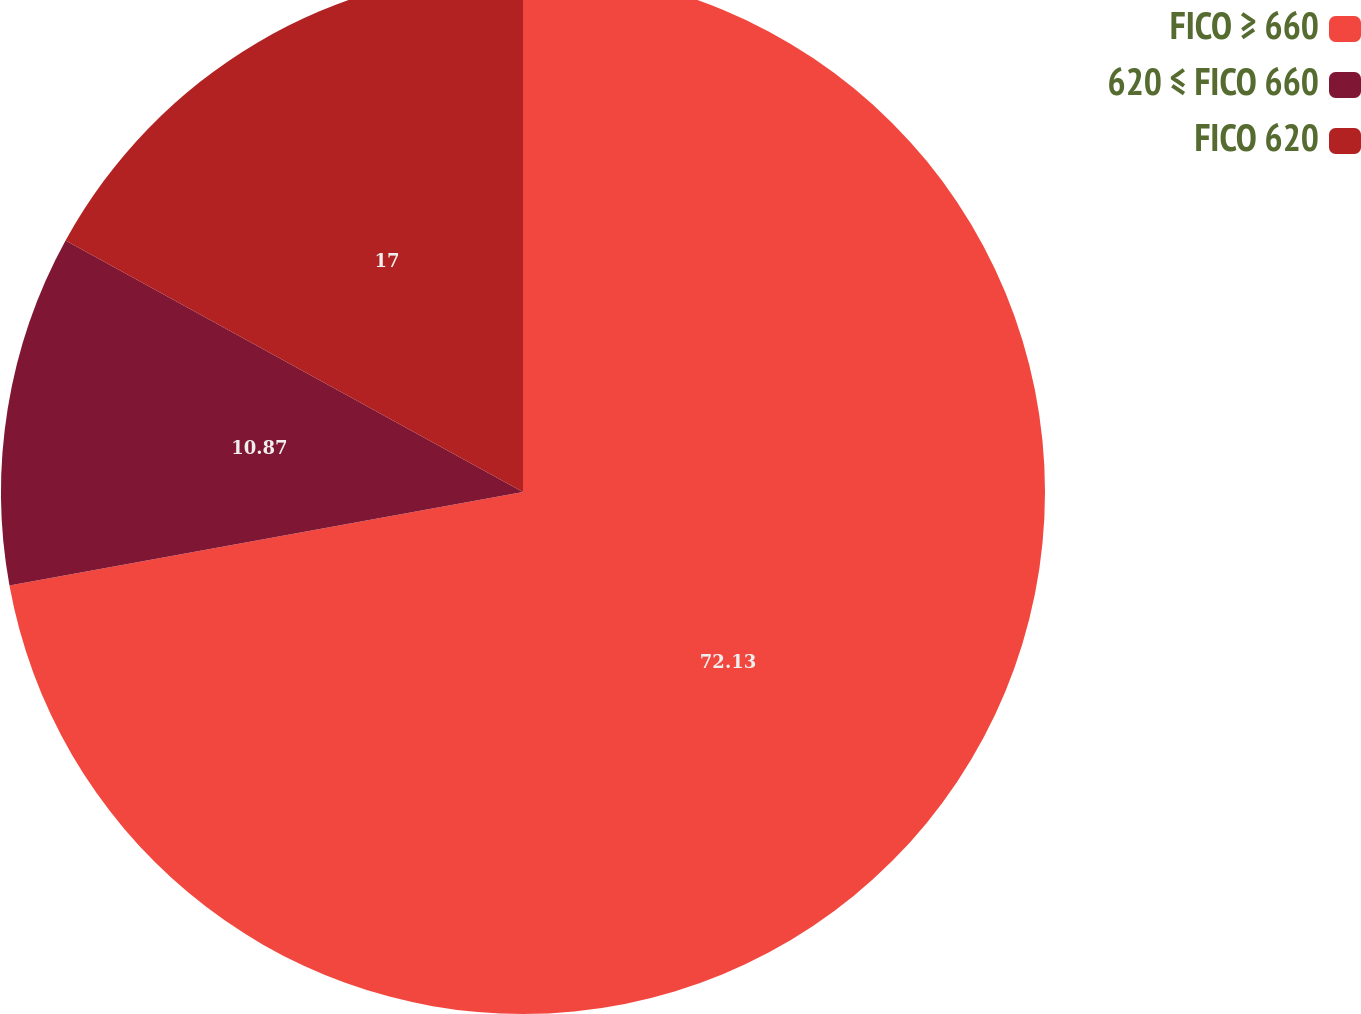Convert chart to OTSL. <chart><loc_0><loc_0><loc_500><loc_500><pie_chart><fcel>FICO ≥ 660<fcel>620 ≤ FICO 660<fcel>FICO 620<nl><fcel>72.13%<fcel>10.87%<fcel>17.0%<nl></chart> 